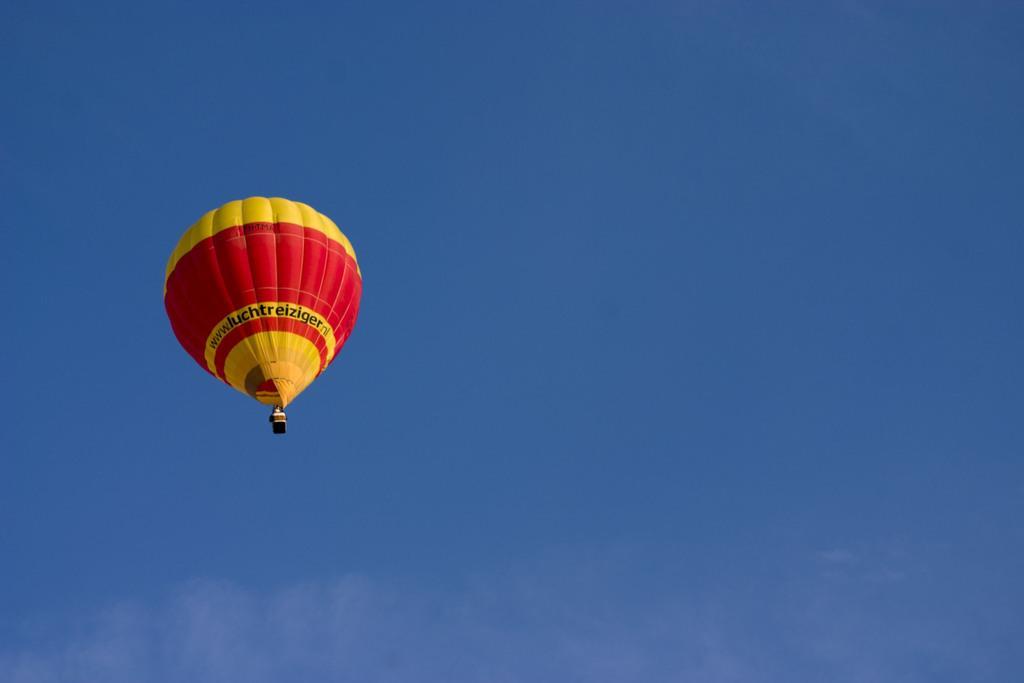Describe this image in one or two sentences. In this image, we can see a parachute in the sky. 